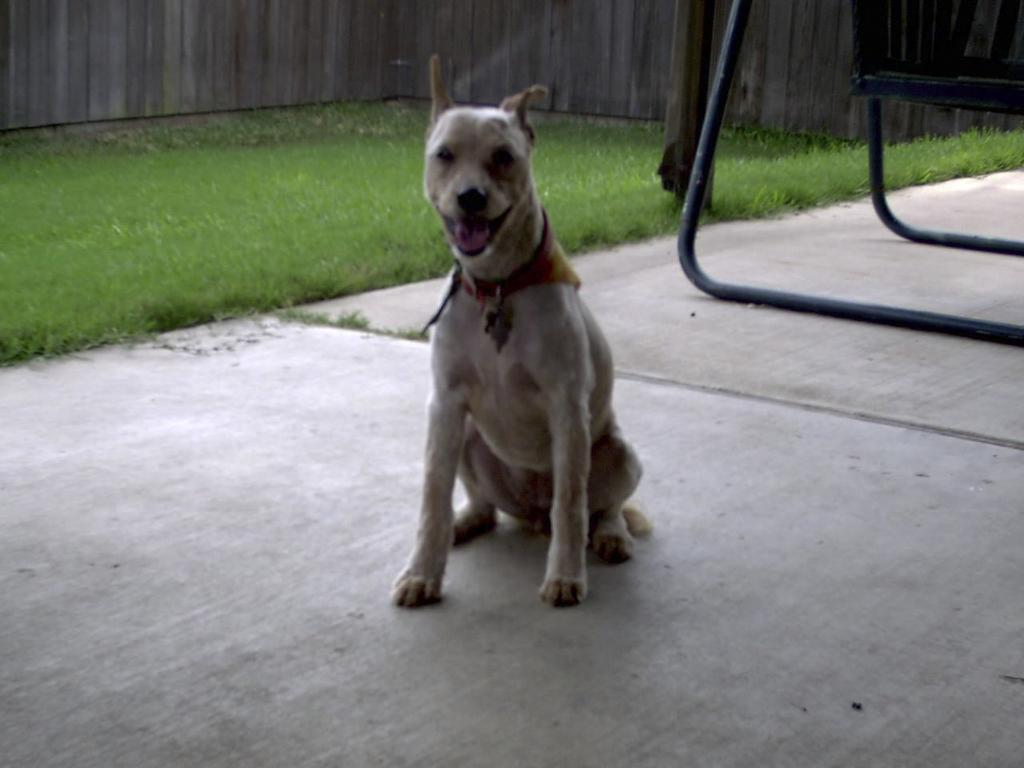What type of animal can be seen in the image? There is a dog in the image. What is the surface that the dog is standing on? The ground is visible in the image. What type of vegetation is present in the image? There is grass in the image. What structure can be seen in the image? There is a pole in the image. What material is the metal object made of? The metal object in the image is made of metal. What type of wall is present in the image? There is a wooden wall in the image. What knowledge does the dog possess about quantum physics in the image? There is no indication in the image that the dog has any knowledge about quantum physics. 